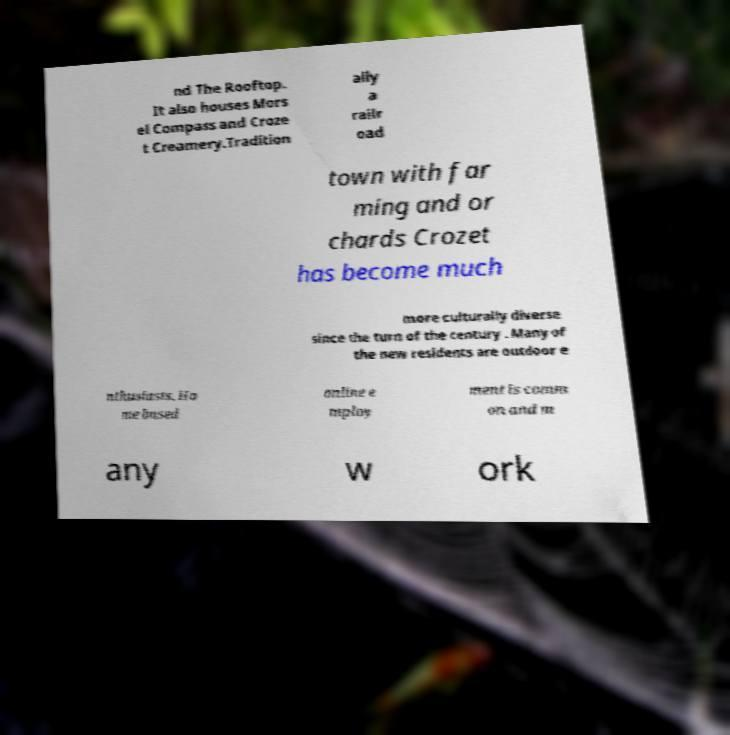Please read and relay the text visible in this image. What does it say? nd The Rooftop. It also houses Mors el Compass and Croze t Creamery.Tradition ally a railr oad town with far ming and or chards Crozet has become much more culturally diverse since the turn of the century . Many of the new residents are outdoor e nthusiasts. Ho me based online e mploy ment is comm on and m any w ork 